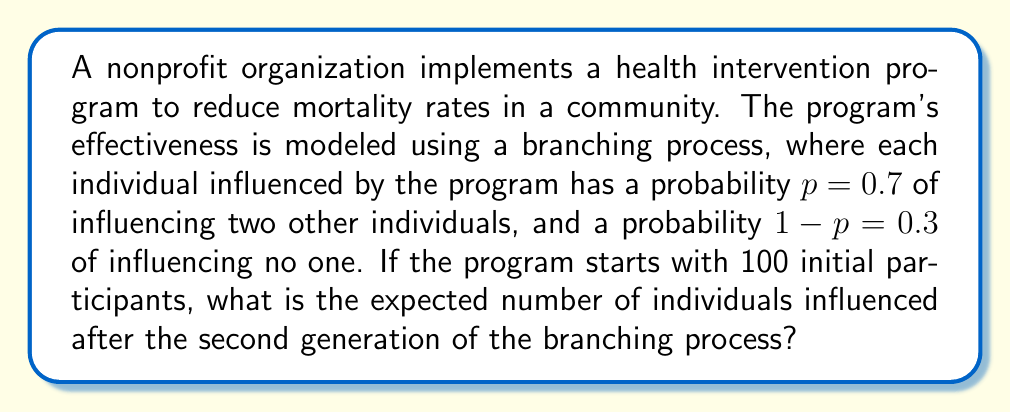Can you solve this math problem? Let's approach this step-by-step:

1) In a branching process, we first need to calculate the expected number of offspring (influenced individuals) per person. Let's call this $\mu$.

   $\mu = 2p + 0(1-p) = 2(0.7) + 0(0.3) = 1.4$

2) For the first generation:
   - We start with 100 participants
   - Each participant is expected to influence 1.4 people
   - So, the expected number in the first generation is:
     
     $E(X_1) = 100 \cdot 1.4 = 140$

3) For the second generation:
   - Each person from the first generation is again expected to influence 1.4 people
   - So, the expected number in the second generation is:
     
     $E(X_2) = E(X_1) \cdot 1.4 = 140 \cdot 1.4 = 196$

4) The total number of individuals influenced after the second generation includes:
   - The initial 100 participants
   - The first generation: 140
   - The second generation: 196

5) Therefore, the total expected number is:

   $E(\text{Total}) = 100 + 140 + 196 = 436$
Answer: 436 